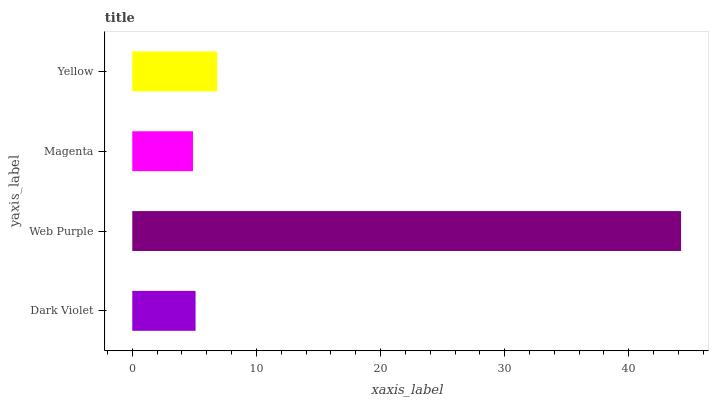Is Magenta the minimum?
Answer yes or no. Yes. Is Web Purple the maximum?
Answer yes or no. Yes. Is Web Purple the minimum?
Answer yes or no. No. Is Magenta the maximum?
Answer yes or no. No. Is Web Purple greater than Magenta?
Answer yes or no. Yes. Is Magenta less than Web Purple?
Answer yes or no. Yes. Is Magenta greater than Web Purple?
Answer yes or no. No. Is Web Purple less than Magenta?
Answer yes or no. No. Is Yellow the high median?
Answer yes or no. Yes. Is Dark Violet the low median?
Answer yes or no. Yes. Is Dark Violet the high median?
Answer yes or no. No. Is Magenta the low median?
Answer yes or no. No. 